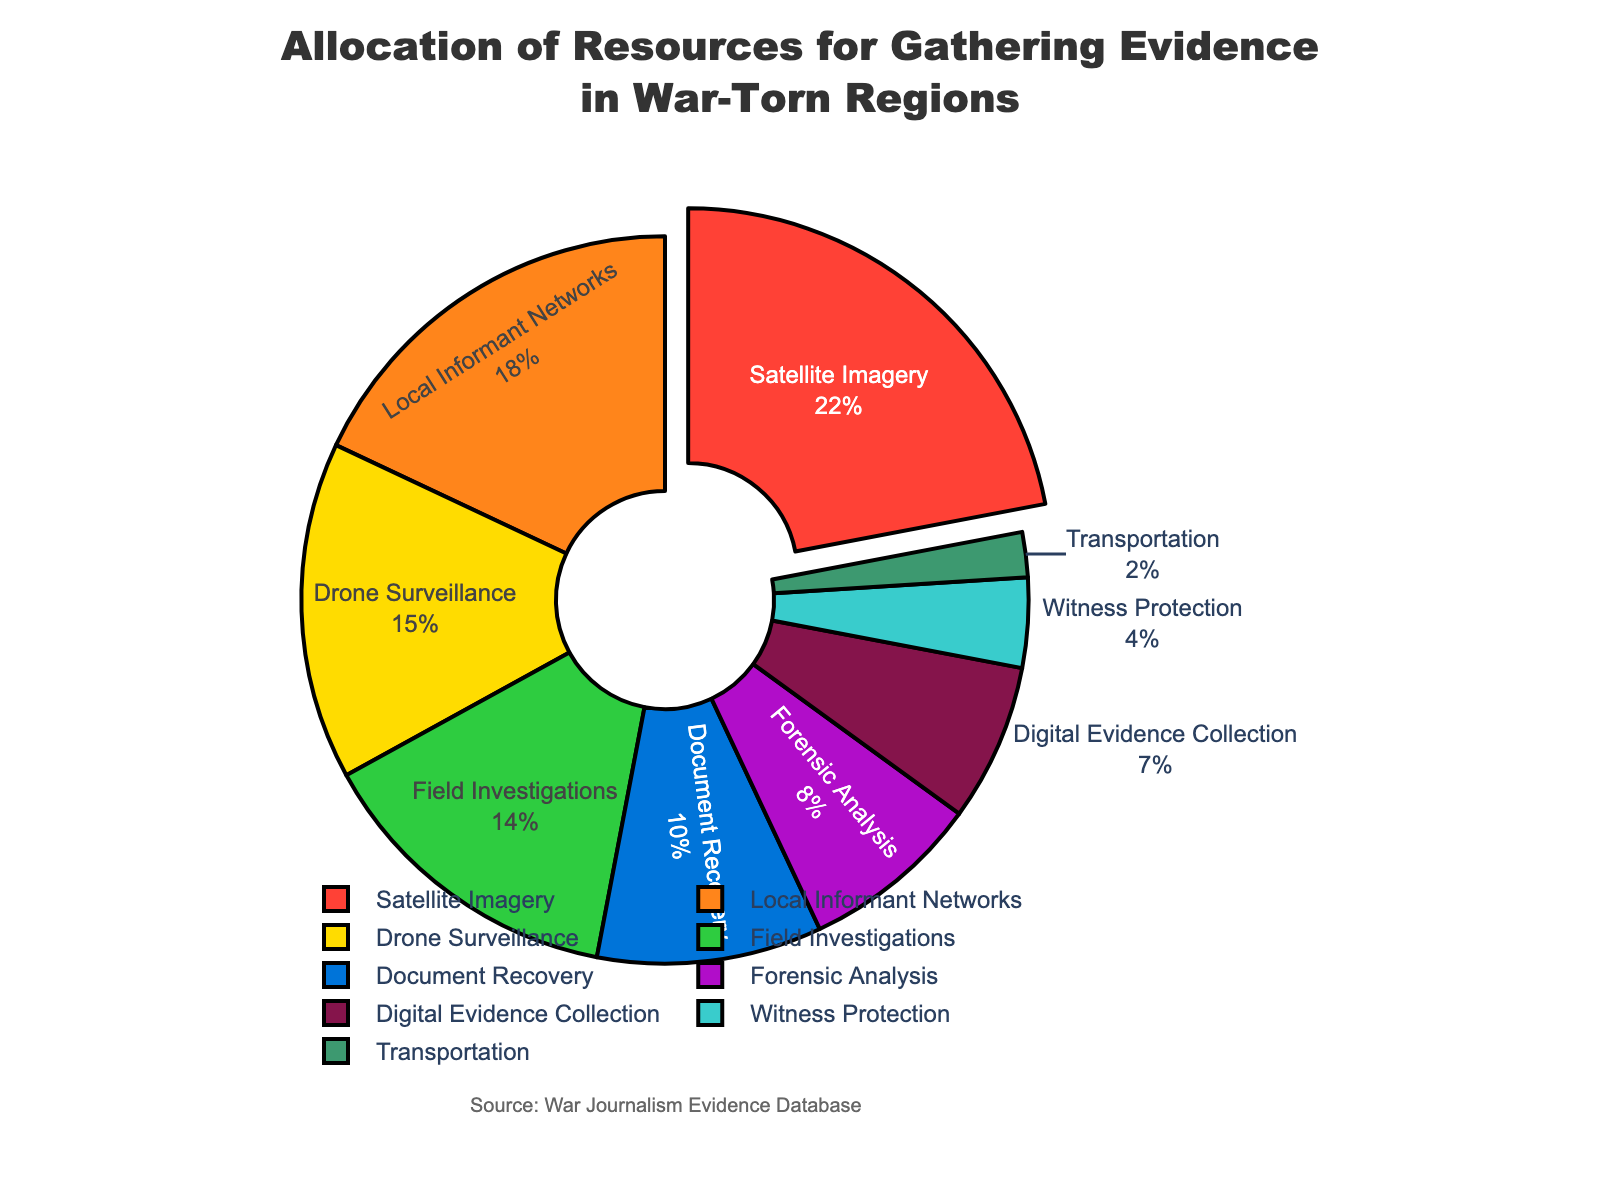Which category has the highest allocation of resources? The category with the highest allocation of resources is the one where the wedge in the pie chart is pulled out. In this chart, it is Satellite Imagery with 22%.
Answer: Satellite Imagery Which two categories combined make up more than 30% of the total allocation? Add the percentages of the top two categories: Satellite Imagery (22%) and Local Informant Networks (18%), which sum to 40%. Since 40% is greater than 30%, these two categories combined make up more than 30%.
Answer: Satellite Imagery and Local Informant Networks How much more percentage is allocated to Drone Surveillance compared to Witness Protection? To find the difference, subtract the percentage of Witness Protection (4%) from the percentage of Drone Surveillance (15%): 15% - 4% = 11%.
Answer: 11% What is the total percentage allocated to Document Recovery and Forensic Analysis combined? Add the percentages of Document Recovery (10%) and Forensic Analysis (8%): 10% + 8% = 18%.
Answer: 18% Which category has the smallest allocation of resources? The category with the smallest wedge in the pie chart represents the smallest allocation. In this chart, it is Transportation, which has 2%.
Answer: Transportation What percentage of resources are allocated to Local Informant Networks and Field Investigations combined? Add the percentages of Local Informant Networks (18%) and Field Investigations (14%): 18% + 14% = 32%.
Answer: 32% Is the allocation to Digital Evidence Collection greater than or less than that to Forensic Analysis? Compare the percentages: Digital Evidence Collection (7%) and Forensic Analysis (8%). 7% is less than 8%.
Answer: Less than What percentage of resources are allocated to categories with less than 10% each? Combine the percentages of Document Recovery (10%), Forensic Analysis (8%), Digital Evidence Collection (7%), Witness Protection (4%), and Transportation (2%). Total = 10% + 8% + 7% + 4% + 2% = 31%. Note that Document Recovery is precisely 10%, so it is included.
Answer: 31% What is the difference in resource allocation between the highest and lowest categories? Subtract the percentage of the lowest category Transportation (2%) from the highest category Satellite Imagery (22%): 22% - 2% = 20%.
Answer: 20% 